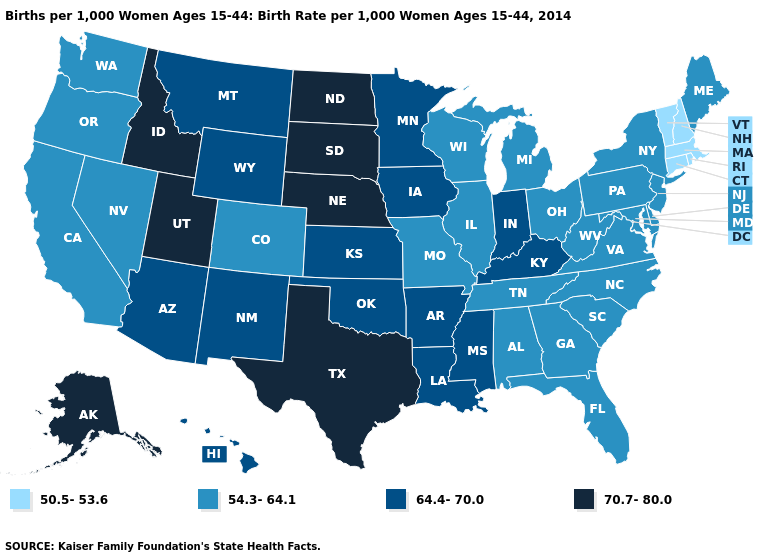Name the states that have a value in the range 54.3-64.1?
Give a very brief answer. Alabama, California, Colorado, Delaware, Florida, Georgia, Illinois, Maine, Maryland, Michigan, Missouri, Nevada, New Jersey, New York, North Carolina, Ohio, Oregon, Pennsylvania, South Carolina, Tennessee, Virginia, Washington, West Virginia, Wisconsin. Does Oklahoma have a lower value than New Jersey?
Concise answer only. No. Name the states that have a value in the range 64.4-70.0?
Concise answer only. Arizona, Arkansas, Hawaii, Indiana, Iowa, Kansas, Kentucky, Louisiana, Minnesota, Mississippi, Montana, New Mexico, Oklahoma, Wyoming. Does Mississippi have the same value as Indiana?
Be succinct. Yes. Name the states that have a value in the range 64.4-70.0?
Short answer required. Arizona, Arkansas, Hawaii, Indiana, Iowa, Kansas, Kentucky, Louisiana, Minnesota, Mississippi, Montana, New Mexico, Oklahoma, Wyoming. Which states hav the highest value in the Northeast?
Keep it brief. Maine, New Jersey, New York, Pennsylvania. What is the value of New Mexico?
Short answer required. 64.4-70.0. Name the states that have a value in the range 70.7-80.0?
Quick response, please. Alaska, Idaho, Nebraska, North Dakota, South Dakota, Texas, Utah. Name the states that have a value in the range 64.4-70.0?
Keep it brief. Arizona, Arkansas, Hawaii, Indiana, Iowa, Kansas, Kentucky, Louisiana, Minnesota, Mississippi, Montana, New Mexico, Oklahoma, Wyoming. Does Delaware have a lower value than Mississippi?
Be succinct. Yes. Name the states that have a value in the range 70.7-80.0?
Quick response, please. Alaska, Idaho, Nebraska, North Dakota, South Dakota, Texas, Utah. Does Maine have the highest value in the Northeast?
Quick response, please. Yes. What is the highest value in states that border Massachusetts?
Write a very short answer. 54.3-64.1. What is the value of Virginia?
Quick response, please. 54.3-64.1. What is the highest value in states that border Missouri?
Write a very short answer. 70.7-80.0. 